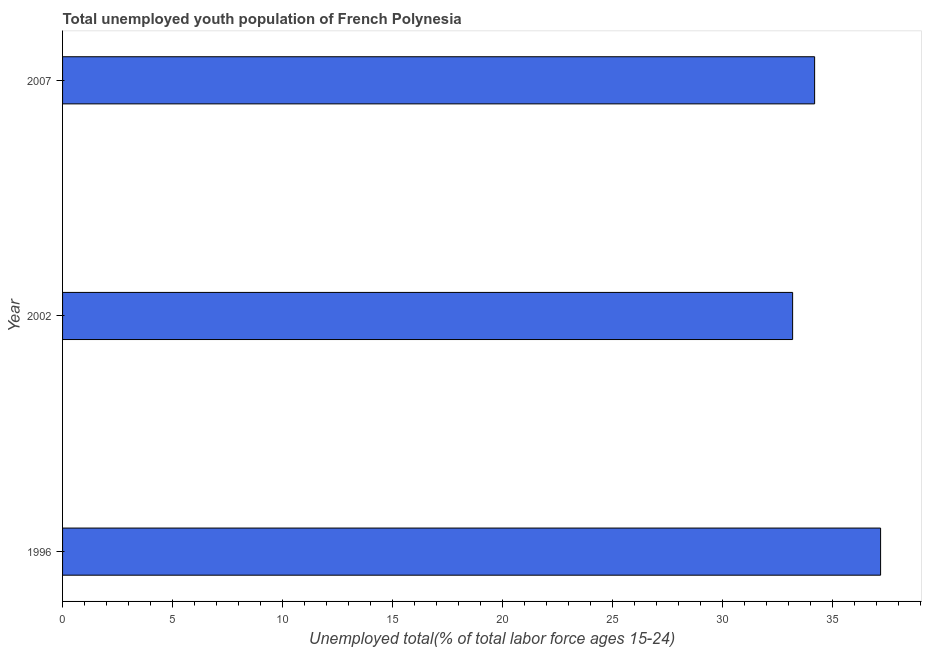Does the graph contain any zero values?
Provide a short and direct response. No. Does the graph contain grids?
Give a very brief answer. No. What is the title of the graph?
Keep it short and to the point. Total unemployed youth population of French Polynesia. What is the label or title of the X-axis?
Keep it short and to the point. Unemployed total(% of total labor force ages 15-24). What is the label or title of the Y-axis?
Your answer should be compact. Year. What is the unemployed youth in 2007?
Your answer should be very brief. 34.2. Across all years, what is the maximum unemployed youth?
Make the answer very short. 37.2. Across all years, what is the minimum unemployed youth?
Ensure brevity in your answer.  33.2. In which year was the unemployed youth maximum?
Ensure brevity in your answer.  1996. What is the sum of the unemployed youth?
Offer a very short reply. 104.6. What is the difference between the unemployed youth in 1996 and 2002?
Give a very brief answer. 4. What is the average unemployed youth per year?
Provide a short and direct response. 34.87. What is the median unemployed youth?
Offer a terse response. 34.2. What is the ratio of the unemployed youth in 1996 to that in 2007?
Your response must be concise. 1.09. Is the unemployed youth in 2002 less than that in 2007?
Keep it short and to the point. Yes. Is the difference between the unemployed youth in 1996 and 2007 greater than the difference between any two years?
Your answer should be compact. No. What is the difference between the highest and the second highest unemployed youth?
Provide a short and direct response. 3. Is the sum of the unemployed youth in 1996 and 2007 greater than the maximum unemployed youth across all years?
Your answer should be compact. Yes. Are all the bars in the graph horizontal?
Your response must be concise. Yes. How many years are there in the graph?
Make the answer very short. 3. What is the Unemployed total(% of total labor force ages 15-24) of 1996?
Your answer should be compact. 37.2. What is the Unemployed total(% of total labor force ages 15-24) of 2002?
Your answer should be very brief. 33.2. What is the Unemployed total(% of total labor force ages 15-24) in 2007?
Make the answer very short. 34.2. What is the difference between the Unemployed total(% of total labor force ages 15-24) in 1996 and 2007?
Ensure brevity in your answer.  3. What is the difference between the Unemployed total(% of total labor force ages 15-24) in 2002 and 2007?
Offer a very short reply. -1. What is the ratio of the Unemployed total(% of total labor force ages 15-24) in 1996 to that in 2002?
Offer a terse response. 1.12. What is the ratio of the Unemployed total(% of total labor force ages 15-24) in 1996 to that in 2007?
Give a very brief answer. 1.09. 